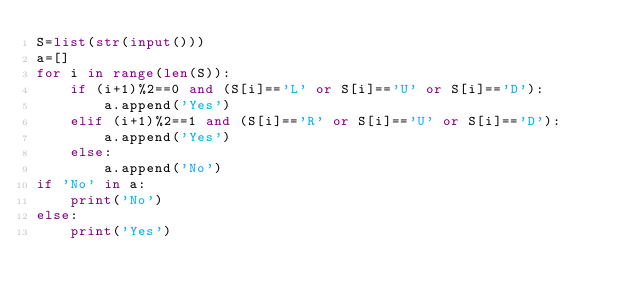<code> <loc_0><loc_0><loc_500><loc_500><_Python_>S=list(str(input()))
a=[]
for i in range(len(S)):
    if (i+1)%2==0 and (S[i]=='L' or S[i]=='U' or S[i]=='D'):
        a.append('Yes')
    elif (i+1)%2==1 and (S[i]=='R' or S[i]=='U' or S[i]=='D'):
        a.append('Yes')
    else:
        a.append('No')
if 'No' in a:
    print('No')
else:
    print('Yes')</code> 